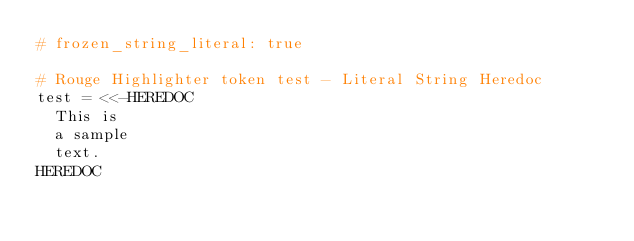<code> <loc_0><loc_0><loc_500><loc_500><_Ruby_># frozen_string_literal: true

# Rouge Highlighter token test - Literal String Heredoc
test = <<-HEREDOC
  This is
  a sample
  text.
HEREDOC
</code> 